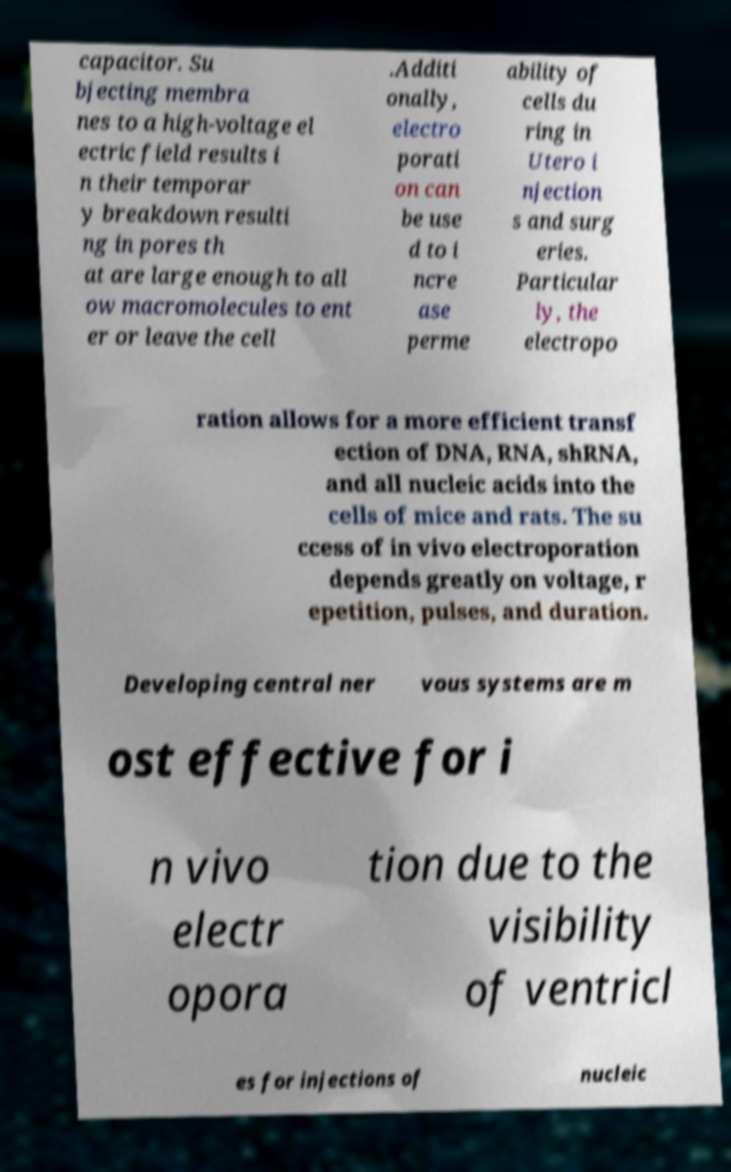There's text embedded in this image that I need extracted. Can you transcribe it verbatim? capacitor. Su bjecting membra nes to a high-voltage el ectric field results i n their temporar y breakdown resulti ng in pores th at are large enough to all ow macromolecules to ent er or leave the cell .Additi onally, electro porati on can be use d to i ncre ase perme ability of cells du ring in Utero i njection s and surg eries. Particular ly, the electropo ration allows for a more efficient transf ection of DNA, RNA, shRNA, and all nucleic acids into the cells of mice and rats. The su ccess of in vivo electroporation depends greatly on voltage, r epetition, pulses, and duration. Developing central ner vous systems are m ost effective for i n vivo electr opora tion due to the visibility of ventricl es for injections of nucleic 